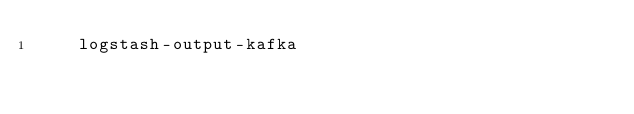Convert code to text. <code><loc_0><loc_0><loc_500><loc_500><_Dockerfile_>    logstash-output-kafka

</code> 